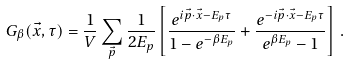Convert formula to latex. <formula><loc_0><loc_0><loc_500><loc_500>G _ { \beta } ( \vec { x } , \tau ) = { \frac { 1 } { V } } \sum _ { \vec { p } } { \frac { 1 } { 2 E _ { p } } } \left [ { \frac { e ^ { i \vec { p } \cdot \vec { x } - E _ { p } \tau } } { 1 - e ^ { - \beta E _ { p } } } } + { \frac { e ^ { - i \vec { p } \cdot \vec { x } - E _ { p } \tau } } { e ^ { \beta E _ { p } } - 1 } } \right ] \, .</formula> 